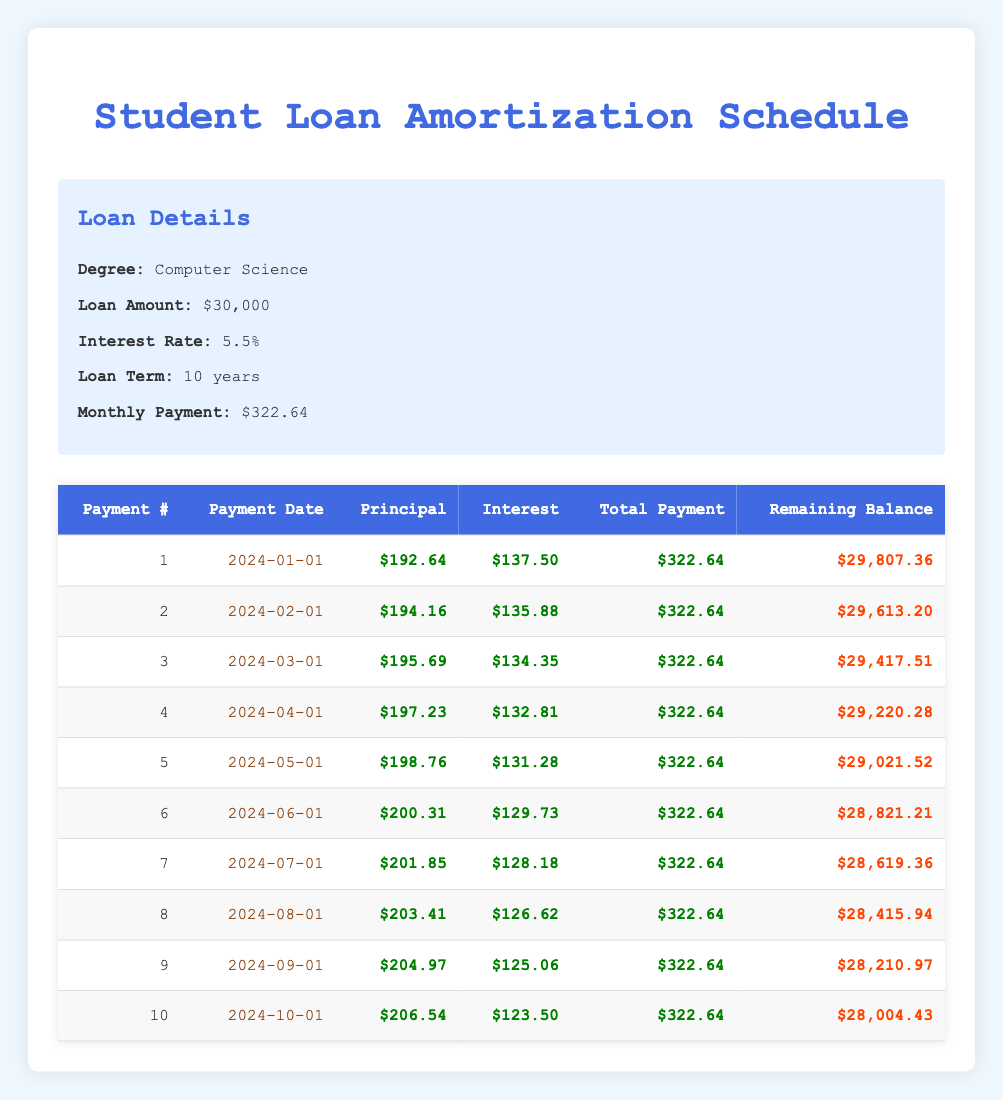What is the total payment for the first month? The total payment for the first month is displayed in the table under the "Total Payment" column for payment number 1. It shows $322.64.
Answer: $322.64 How much of the second payment goes towards principal? The principal payment for the second month is found in the table in the "Principal" column for payment number 2. It shows $194.16.
Answer: $194.16 What is the remaining balance after the fifth payment? The remaining balance after the fifth payment is recorded in the "Remaining Balance" column for payment number 5. It is shown as $29,021.52.
Answer: $29,021.52 Is the interest payment decreasing every month? To determine if the interest payment is decreasing, we can compare the interest payment values for each month. The interest payment for payment number 1 is $137.50, and for payment number 2, it is $135.88, which indicates a decrease. This trend continues for the following months, confirming that the interest payment is indeed decreasing.
Answer: Yes What is the average principal payment over the first ten months? To find the average principal payment, we need to sum the principal payments from each month: $192.64 + $194.16 + $195.69 + $197.23 + $198.76 + $200.31 + $201.85 + $203.41 + $204.97 + $206.54 = $1,975.56. Then divide this sum by the number of payments (10), giving us an average of $197.56.
Answer: $197.56 How much total interest is paid in the first three months? To calculate the total interest paid in the first three months, we sum the interest payments for the respective months: $137.50 (month 1) + $135.88 (month 2) + $134.35 (month 3) = $407.73.
Answer: $407.73 What is the principal payment for the third month? The principal payment for the third month can be found in the table under the "Principal" column for payment number 3, which is listed as $195.69.
Answer: $195.69 Is the total payment the same for each month? Observing the table, we can see that the "Total Payment" column consistently shows $322.64 for all months, indicating that it remains the same throughout.
Answer: Yes What is the difference in remaining balance between the first and the last payment shown? The remaining balance after the first payment is $29,807.36 and after the last (tenth) payment is $28,004.43. The difference is calculated as $29,807.36 - $28,004.43 = $1,802.93.
Answer: $1,802.93 